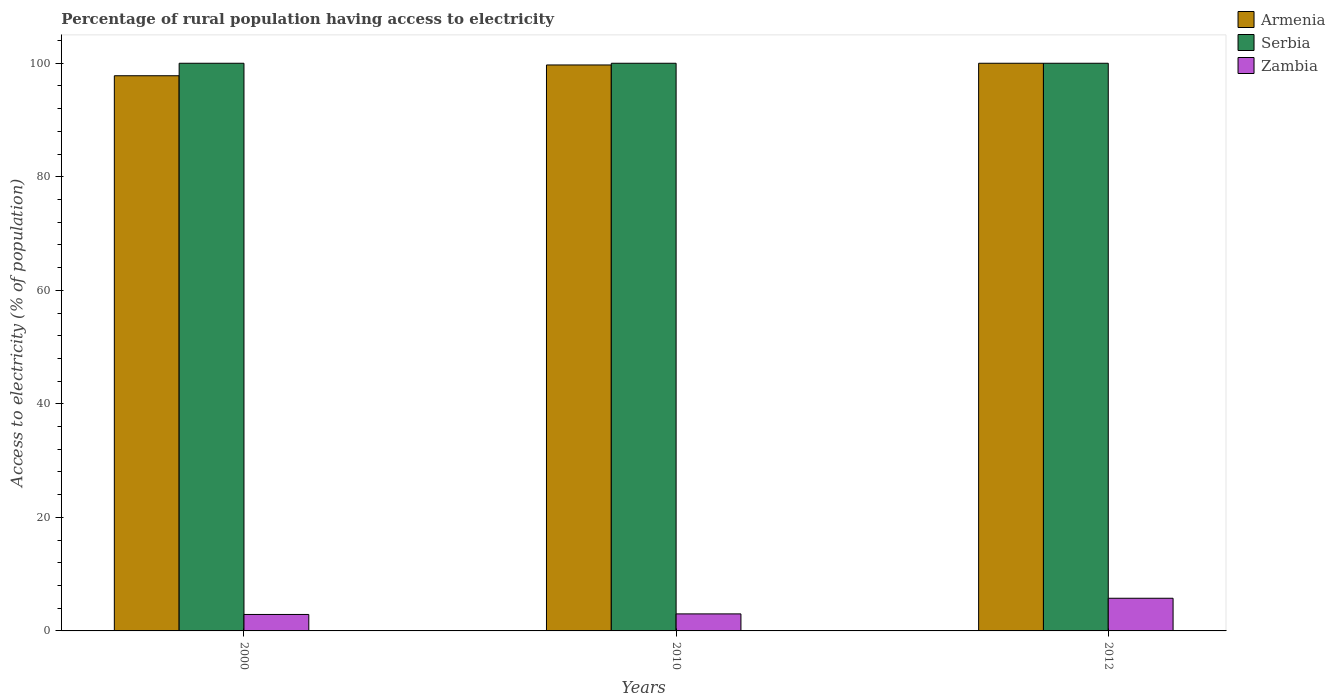How many different coloured bars are there?
Give a very brief answer. 3. How many groups of bars are there?
Give a very brief answer. 3. Are the number of bars per tick equal to the number of legend labels?
Provide a short and direct response. Yes. Are the number of bars on each tick of the X-axis equal?
Your answer should be very brief. Yes. How many bars are there on the 3rd tick from the left?
Keep it short and to the point. 3. Across all years, what is the maximum percentage of rural population having access to electricity in Serbia?
Your response must be concise. 100. Across all years, what is the minimum percentage of rural population having access to electricity in Serbia?
Provide a succinct answer. 100. In which year was the percentage of rural population having access to electricity in Serbia maximum?
Keep it short and to the point. 2000. In which year was the percentage of rural population having access to electricity in Zambia minimum?
Your answer should be very brief. 2000. What is the total percentage of rural population having access to electricity in Serbia in the graph?
Provide a succinct answer. 300. What is the difference between the percentage of rural population having access to electricity in Zambia in 2010 and that in 2012?
Keep it short and to the point. -2.75. What is the difference between the percentage of rural population having access to electricity in Armenia in 2000 and the percentage of rural population having access to electricity in Serbia in 2010?
Provide a succinct answer. -2.2. What is the average percentage of rural population having access to electricity in Serbia per year?
Ensure brevity in your answer.  100. In the year 2000, what is the difference between the percentage of rural population having access to electricity in Armenia and percentage of rural population having access to electricity in Serbia?
Your answer should be compact. -2.2. In how many years, is the percentage of rural population having access to electricity in Zambia greater than 48 %?
Your response must be concise. 0. What is the ratio of the percentage of rural population having access to electricity in Zambia in 2010 to that in 2012?
Your answer should be compact. 0.52. Is the difference between the percentage of rural population having access to electricity in Armenia in 2000 and 2012 greater than the difference between the percentage of rural population having access to electricity in Serbia in 2000 and 2012?
Your answer should be compact. No. What is the difference between the highest and the second highest percentage of rural population having access to electricity in Armenia?
Ensure brevity in your answer.  0.3. What is the difference between the highest and the lowest percentage of rural population having access to electricity in Serbia?
Offer a very short reply. 0. In how many years, is the percentage of rural population having access to electricity in Zambia greater than the average percentage of rural population having access to electricity in Zambia taken over all years?
Provide a short and direct response. 1. Is the sum of the percentage of rural population having access to electricity in Zambia in 2010 and 2012 greater than the maximum percentage of rural population having access to electricity in Armenia across all years?
Give a very brief answer. No. What does the 1st bar from the left in 2010 represents?
Your answer should be very brief. Armenia. What does the 3rd bar from the right in 2010 represents?
Make the answer very short. Armenia. Is it the case that in every year, the sum of the percentage of rural population having access to electricity in Serbia and percentage of rural population having access to electricity in Armenia is greater than the percentage of rural population having access to electricity in Zambia?
Keep it short and to the point. Yes. How many bars are there?
Give a very brief answer. 9. Does the graph contain any zero values?
Your answer should be compact. No. Does the graph contain grids?
Provide a short and direct response. No. Where does the legend appear in the graph?
Offer a terse response. Top right. How are the legend labels stacked?
Provide a succinct answer. Vertical. What is the title of the graph?
Provide a short and direct response. Percentage of rural population having access to electricity. What is the label or title of the Y-axis?
Ensure brevity in your answer.  Access to electricity (% of population). What is the Access to electricity (% of population) in Armenia in 2000?
Your answer should be very brief. 97.8. What is the Access to electricity (% of population) in Armenia in 2010?
Keep it short and to the point. 99.7. What is the Access to electricity (% of population) in Serbia in 2012?
Keep it short and to the point. 100. What is the Access to electricity (% of population) of Zambia in 2012?
Give a very brief answer. 5.75. Across all years, what is the maximum Access to electricity (% of population) in Serbia?
Make the answer very short. 100. Across all years, what is the maximum Access to electricity (% of population) in Zambia?
Offer a very short reply. 5.75. Across all years, what is the minimum Access to electricity (% of population) in Armenia?
Make the answer very short. 97.8. What is the total Access to electricity (% of population) in Armenia in the graph?
Provide a short and direct response. 297.5. What is the total Access to electricity (% of population) in Serbia in the graph?
Provide a succinct answer. 300. What is the total Access to electricity (% of population) in Zambia in the graph?
Provide a succinct answer. 11.65. What is the difference between the Access to electricity (% of population) in Armenia in 2000 and that in 2010?
Ensure brevity in your answer.  -1.9. What is the difference between the Access to electricity (% of population) in Serbia in 2000 and that in 2010?
Keep it short and to the point. 0. What is the difference between the Access to electricity (% of population) in Zambia in 2000 and that in 2010?
Your answer should be very brief. -0.1. What is the difference between the Access to electricity (% of population) in Zambia in 2000 and that in 2012?
Ensure brevity in your answer.  -2.85. What is the difference between the Access to electricity (% of population) of Serbia in 2010 and that in 2012?
Offer a very short reply. 0. What is the difference between the Access to electricity (% of population) of Zambia in 2010 and that in 2012?
Make the answer very short. -2.75. What is the difference between the Access to electricity (% of population) in Armenia in 2000 and the Access to electricity (% of population) in Zambia in 2010?
Give a very brief answer. 94.8. What is the difference between the Access to electricity (% of population) in Serbia in 2000 and the Access to electricity (% of population) in Zambia in 2010?
Your answer should be very brief. 97. What is the difference between the Access to electricity (% of population) in Armenia in 2000 and the Access to electricity (% of population) in Zambia in 2012?
Provide a succinct answer. 92.05. What is the difference between the Access to electricity (% of population) in Serbia in 2000 and the Access to electricity (% of population) in Zambia in 2012?
Provide a short and direct response. 94.25. What is the difference between the Access to electricity (% of population) of Armenia in 2010 and the Access to electricity (% of population) of Zambia in 2012?
Your response must be concise. 93.95. What is the difference between the Access to electricity (% of population) of Serbia in 2010 and the Access to electricity (% of population) of Zambia in 2012?
Make the answer very short. 94.25. What is the average Access to electricity (% of population) of Armenia per year?
Provide a short and direct response. 99.17. What is the average Access to electricity (% of population) of Zambia per year?
Offer a very short reply. 3.88. In the year 2000, what is the difference between the Access to electricity (% of population) of Armenia and Access to electricity (% of population) of Serbia?
Your answer should be compact. -2.2. In the year 2000, what is the difference between the Access to electricity (% of population) of Armenia and Access to electricity (% of population) of Zambia?
Offer a very short reply. 94.9. In the year 2000, what is the difference between the Access to electricity (% of population) of Serbia and Access to electricity (% of population) of Zambia?
Provide a succinct answer. 97.1. In the year 2010, what is the difference between the Access to electricity (% of population) in Armenia and Access to electricity (% of population) in Zambia?
Offer a very short reply. 96.7. In the year 2010, what is the difference between the Access to electricity (% of population) in Serbia and Access to electricity (% of population) in Zambia?
Provide a short and direct response. 97. In the year 2012, what is the difference between the Access to electricity (% of population) in Armenia and Access to electricity (% of population) in Zambia?
Your response must be concise. 94.25. In the year 2012, what is the difference between the Access to electricity (% of population) in Serbia and Access to electricity (% of population) in Zambia?
Ensure brevity in your answer.  94.25. What is the ratio of the Access to electricity (% of population) in Armenia in 2000 to that in 2010?
Your response must be concise. 0.98. What is the ratio of the Access to electricity (% of population) of Serbia in 2000 to that in 2010?
Give a very brief answer. 1. What is the ratio of the Access to electricity (% of population) of Zambia in 2000 to that in 2010?
Your response must be concise. 0.97. What is the ratio of the Access to electricity (% of population) in Serbia in 2000 to that in 2012?
Your answer should be compact. 1. What is the ratio of the Access to electricity (% of population) in Zambia in 2000 to that in 2012?
Offer a terse response. 0.5. What is the ratio of the Access to electricity (% of population) in Armenia in 2010 to that in 2012?
Provide a short and direct response. 1. What is the ratio of the Access to electricity (% of population) in Zambia in 2010 to that in 2012?
Ensure brevity in your answer.  0.52. What is the difference between the highest and the second highest Access to electricity (% of population) in Zambia?
Offer a terse response. 2.75. What is the difference between the highest and the lowest Access to electricity (% of population) in Armenia?
Your response must be concise. 2.2. What is the difference between the highest and the lowest Access to electricity (% of population) of Zambia?
Your response must be concise. 2.85. 